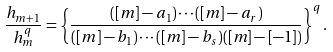<formula> <loc_0><loc_0><loc_500><loc_500>\frac { h _ { m + 1 } } { h _ { m } ^ { q } } = \left \{ \frac { ( [ m ] - a _ { 1 } ) \cdots ( [ m ] - a _ { r } ) } { ( [ m ] - b _ { 1 } ) \cdots ( [ m ] - b _ { s } ) ( [ m ] - [ - 1 ] ) } \right \} ^ { q } .</formula> 